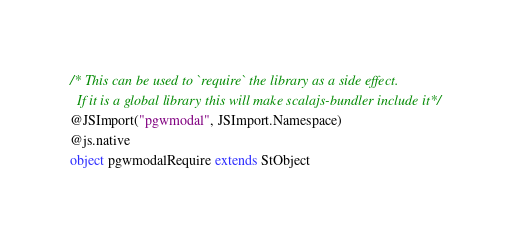<code> <loc_0><loc_0><loc_500><loc_500><_Scala_>/* This can be used to `require` the library as a side effect.
  If it is a global library this will make scalajs-bundler include it */
@JSImport("pgwmodal", JSImport.Namespace)
@js.native
object pgwmodalRequire extends StObject
</code> 